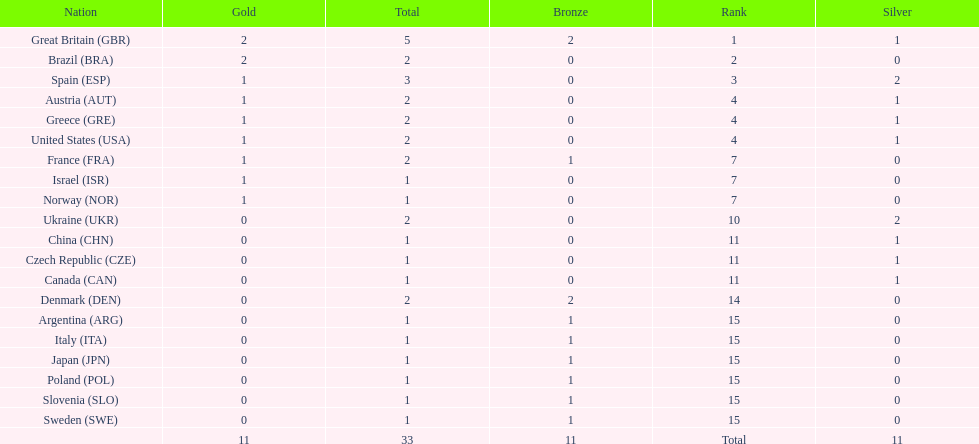What was the number of silver medals won by ukraine? 2. 